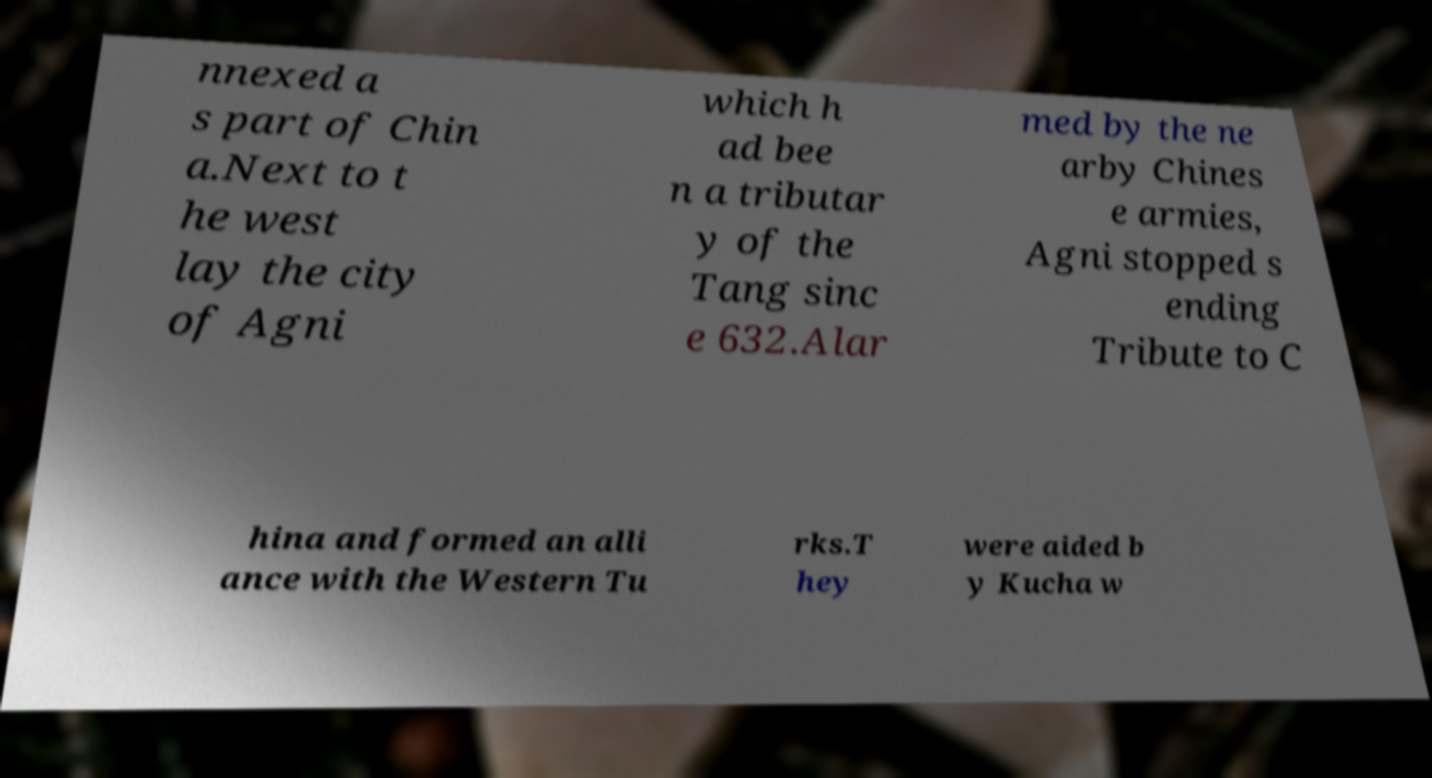Can you read and provide the text displayed in the image?This photo seems to have some interesting text. Can you extract and type it out for me? nnexed a s part of Chin a.Next to t he west lay the city of Agni which h ad bee n a tributar y of the Tang sinc e 632.Alar med by the ne arby Chines e armies, Agni stopped s ending Tribute to C hina and formed an alli ance with the Western Tu rks.T hey were aided b y Kucha w 